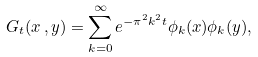Convert formula to latex. <formula><loc_0><loc_0><loc_500><loc_500>G _ { t } ( x \, , y ) = \sum _ { k = 0 } ^ { \infty } e ^ { - \pi ^ { 2 } k ^ { 2 } t } \phi _ { k } ( x ) \phi _ { k } ( y ) ,</formula> 